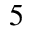<formula> <loc_0><loc_0><loc_500><loc_500>5</formula> 